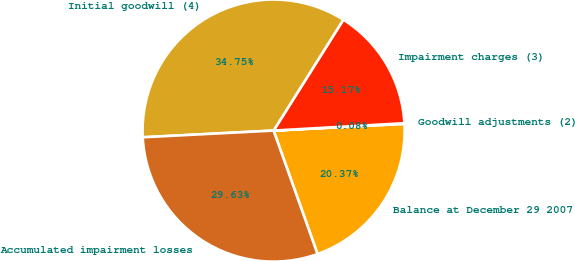<chart> <loc_0><loc_0><loc_500><loc_500><pie_chart><fcel>Balance at December 29 2007<fcel>Goodwill adjustments (2)<fcel>Impairment charges (3)<fcel>Initial goodwill (4)<fcel>Accumulated impairment losses<nl><fcel>20.37%<fcel>0.08%<fcel>15.17%<fcel>34.75%<fcel>29.63%<nl></chart> 